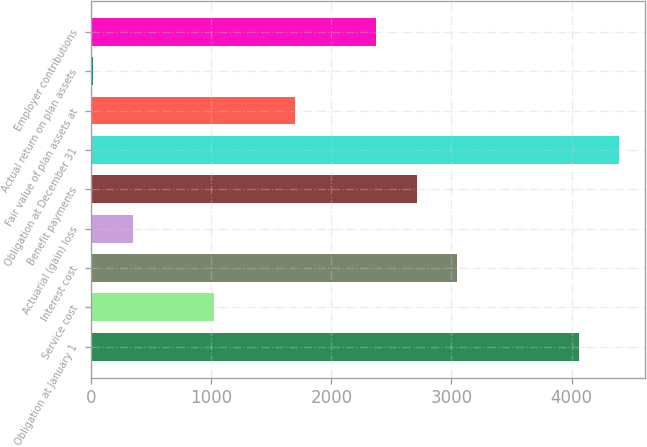Convert chart to OTSL. <chart><loc_0><loc_0><loc_500><loc_500><bar_chart><fcel>Obligation at January 1<fcel>Service cost<fcel>Interest cost<fcel>Actuarial (gain) loss<fcel>Benefit payments<fcel>Obligation at December 31<fcel>Fair value of plan assets at<fcel>Actual return on plan assets<fcel>Employer contributions<nl><fcel>4058.6<fcel>1022.9<fcel>3046.7<fcel>348.3<fcel>2709.4<fcel>4395.9<fcel>1697.5<fcel>11<fcel>2372.1<nl></chart> 